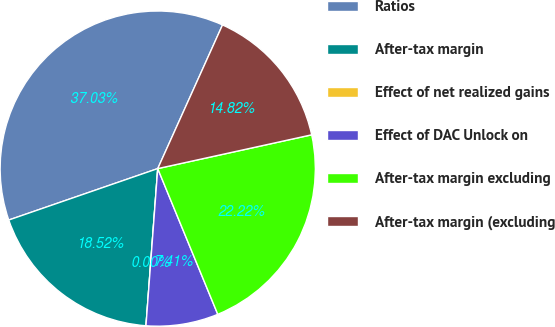Convert chart to OTSL. <chart><loc_0><loc_0><loc_500><loc_500><pie_chart><fcel>Ratios<fcel>After-tax margin<fcel>Effect of net realized gains<fcel>Effect of DAC Unlock on<fcel>After-tax margin excluding<fcel>After-tax margin (excluding<nl><fcel>37.03%<fcel>18.52%<fcel>0.0%<fcel>7.41%<fcel>22.22%<fcel>14.82%<nl></chart> 